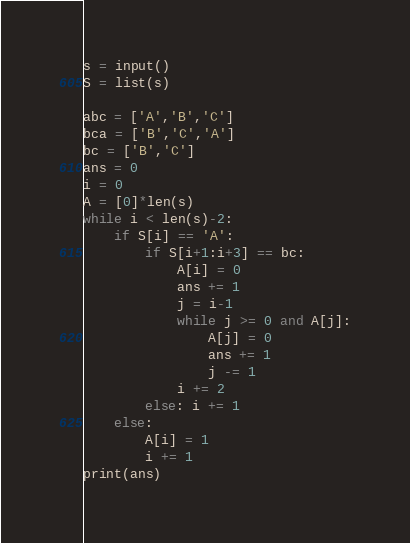<code> <loc_0><loc_0><loc_500><loc_500><_Python_>s = input()
S = list(s)
 
abc = ['A','B','C']
bca = ['B','C','A']
bc = ['B','C']
ans = 0
i = 0
A = [0]*len(s)
while i < len(s)-2:
    if S[i] == 'A':
        if S[i+1:i+3] == bc:
            A[i] = 0
            ans += 1
            j = i-1
            while j >= 0 and A[j]:
                A[j] = 0
                ans += 1
                j -= 1
            i += 2
        else: i += 1
    else:
        A[i] = 1
        i += 1
print(ans)</code> 